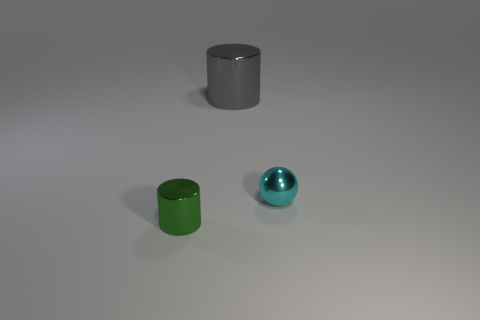Add 1 tiny cyan balls. How many objects exist? 4 Subtract all cylinders. How many objects are left? 1 Add 3 tiny cyan metallic balls. How many tiny cyan metallic balls are left? 4 Add 2 cyan things. How many cyan things exist? 3 Subtract 0 cyan cubes. How many objects are left? 3 Subtract all cyan shiny balls. Subtract all big gray shiny things. How many objects are left? 1 